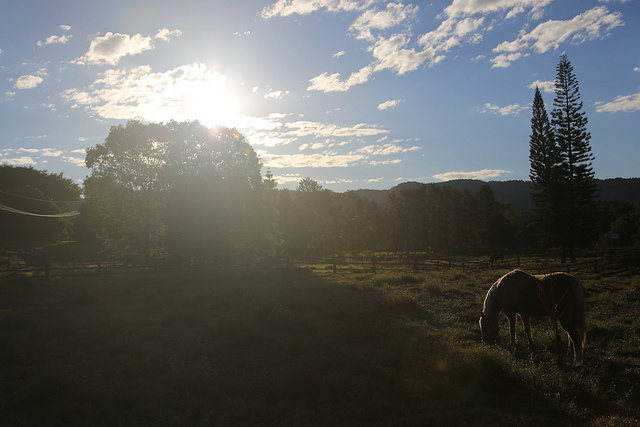How many of the train cars can you see someone sticking their head out of? Based on the image provided, there are no train cars visible, and accordingly, no individuals can be seen sticking their heads out of any train cars. 